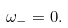<formula> <loc_0><loc_0><loc_500><loc_500>\omega _ { - } = 0 .</formula> 